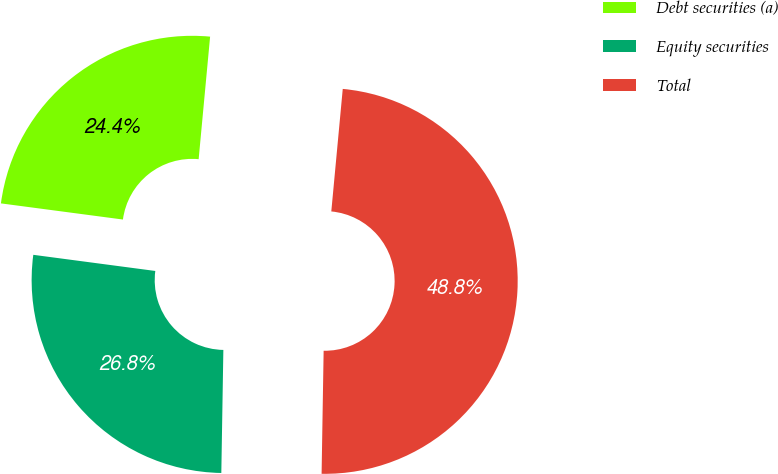Convert chart. <chart><loc_0><loc_0><loc_500><loc_500><pie_chart><fcel>Debt securities (a)<fcel>Equity securities<fcel>Total<nl><fcel>24.39%<fcel>26.83%<fcel>48.78%<nl></chart> 